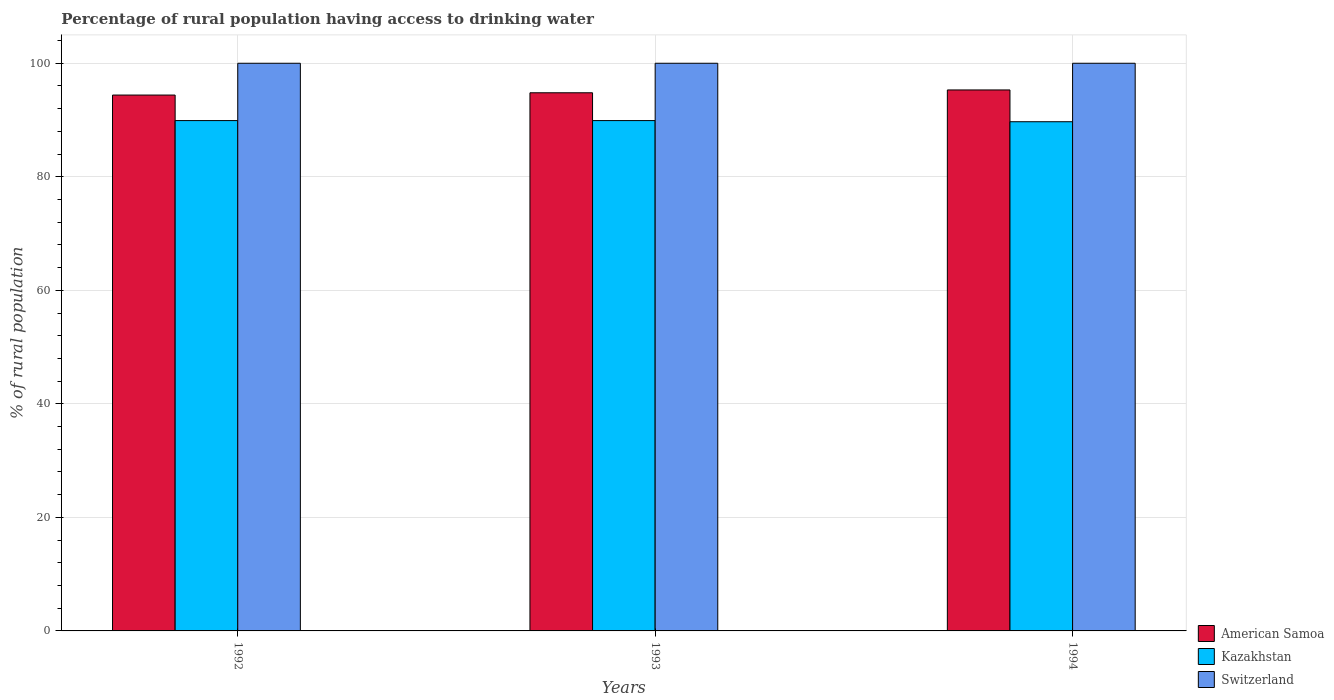How many groups of bars are there?
Offer a very short reply. 3. Are the number of bars per tick equal to the number of legend labels?
Keep it short and to the point. Yes. Are the number of bars on each tick of the X-axis equal?
Offer a very short reply. Yes. How many bars are there on the 2nd tick from the left?
Provide a short and direct response. 3. How many bars are there on the 3rd tick from the right?
Ensure brevity in your answer.  3. What is the label of the 1st group of bars from the left?
Provide a short and direct response. 1992. In how many cases, is the number of bars for a given year not equal to the number of legend labels?
Provide a succinct answer. 0. What is the percentage of rural population having access to drinking water in Kazakhstan in 1992?
Make the answer very short. 89.9. Across all years, what is the maximum percentage of rural population having access to drinking water in Kazakhstan?
Offer a very short reply. 89.9. Across all years, what is the minimum percentage of rural population having access to drinking water in Switzerland?
Your answer should be very brief. 100. In which year was the percentage of rural population having access to drinking water in Kazakhstan maximum?
Give a very brief answer. 1992. In which year was the percentage of rural population having access to drinking water in American Samoa minimum?
Your answer should be compact. 1992. What is the total percentage of rural population having access to drinking water in Switzerland in the graph?
Provide a succinct answer. 300. What is the difference between the percentage of rural population having access to drinking water in Kazakhstan in 1993 and that in 1994?
Keep it short and to the point. 0.2. What is the difference between the percentage of rural population having access to drinking water in Switzerland in 1992 and the percentage of rural population having access to drinking water in Kazakhstan in 1994?
Keep it short and to the point. 10.3. What is the average percentage of rural population having access to drinking water in American Samoa per year?
Your answer should be very brief. 94.83. In the year 1994, what is the difference between the percentage of rural population having access to drinking water in American Samoa and percentage of rural population having access to drinking water in Kazakhstan?
Make the answer very short. 5.6. What is the ratio of the percentage of rural population having access to drinking water in Kazakhstan in 1993 to that in 1994?
Your answer should be very brief. 1. Is the percentage of rural population having access to drinking water in Switzerland in 1992 less than that in 1993?
Provide a short and direct response. No. Is the difference between the percentage of rural population having access to drinking water in American Samoa in 1992 and 1993 greater than the difference between the percentage of rural population having access to drinking water in Kazakhstan in 1992 and 1993?
Your answer should be compact. No. What is the difference between the highest and the second highest percentage of rural population having access to drinking water in Switzerland?
Provide a short and direct response. 0. In how many years, is the percentage of rural population having access to drinking water in Switzerland greater than the average percentage of rural population having access to drinking water in Switzerland taken over all years?
Offer a terse response. 0. Is the sum of the percentage of rural population having access to drinking water in Switzerland in 1993 and 1994 greater than the maximum percentage of rural population having access to drinking water in American Samoa across all years?
Offer a very short reply. Yes. What does the 2nd bar from the left in 1993 represents?
Offer a terse response. Kazakhstan. What does the 2nd bar from the right in 1992 represents?
Make the answer very short. Kazakhstan. What is the difference between two consecutive major ticks on the Y-axis?
Your response must be concise. 20. Are the values on the major ticks of Y-axis written in scientific E-notation?
Your response must be concise. No. Where does the legend appear in the graph?
Your response must be concise. Bottom right. How are the legend labels stacked?
Your response must be concise. Vertical. What is the title of the graph?
Ensure brevity in your answer.  Percentage of rural population having access to drinking water. What is the label or title of the X-axis?
Keep it short and to the point. Years. What is the label or title of the Y-axis?
Provide a succinct answer. % of rural population. What is the % of rural population in American Samoa in 1992?
Provide a short and direct response. 94.4. What is the % of rural population of Kazakhstan in 1992?
Keep it short and to the point. 89.9. What is the % of rural population of Switzerland in 1992?
Your answer should be very brief. 100. What is the % of rural population of American Samoa in 1993?
Make the answer very short. 94.8. What is the % of rural population in Kazakhstan in 1993?
Give a very brief answer. 89.9. What is the % of rural population of Switzerland in 1993?
Ensure brevity in your answer.  100. What is the % of rural population in American Samoa in 1994?
Ensure brevity in your answer.  95.3. What is the % of rural population in Kazakhstan in 1994?
Make the answer very short. 89.7. What is the % of rural population in Switzerland in 1994?
Keep it short and to the point. 100. Across all years, what is the maximum % of rural population of American Samoa?
Your answer should be compact. 95.3. Across all years, what is the maximum % of rural population in Kazakhstan?
Ensure brevity in your answer.  89.9. Across all years, what is the minimum % of rural population in American Samoa?
Your answer should be compact. 94.4. Across all years, what is the minimum % of rural population of Kazakhstan?
Your response must be concise. 89.7. Across all years, what is the minimum % of rural population in Switzerland?
Provide a succinct answer. 100. What is the total % of rural population in American Samoa in the graph?
Offer a terse response. 284.5. What is the total % of rural population of Kazakhstan in the graph?
Your response must be concise. 269.5. What is the total % of rural population of Switzerland in the graph?
Provide a succinct answer. 300. What is the difference between the % of rural population in American Samoa in 1992 and that in 1993?
Your answer should be compact. -0.4. What is the difference between the % of rural population in Kazakhstan in 1992 and that in 1993?
Make the answer very short. 0. What is the difference between the % of rural population of Switzerland in 1992 and that in 1993?
Provide a succinct answer. 0. What is the difference between the % of rural population of American Samoa in 1992 and that in 1994?
Offer a very short reply. -0.9. What is the difference between the % of rural population in Kazakhstan in 1992 and that in 1994?
Offer a very short reply. 0.2. What is the difference between the % of rural population of American Samoa in 1993 and that in 1994?
Provide a short and direct response. -0.5. What is the difference between the % of rural population in Kazakhstan in 1993 and that in 1994?
Provide a succinct answer. 0.2. What is the difference between the % of rural population in Switzerland in 1993 and that in 1994?
Make the answer very short. 0. What is the difference between the % of rural population of Kazakhstan in 1992 and the % of rural population of Switzerland in 1993?
Make the answer very short. -10.1. What is the difference between the % of rural population in American Samoa in 1992 and the % of rural population in Kazakhstan in 1994?
Your answer should be compact. 4.7. What is the difference between the % of rural population of American Samoa in 1993 and the % of rural population of Switzerland in 1994?
Keep it short and to the point. -5.2. What is the average % of rural population of American Samoa per year?
Your answer should be very brief. 94.83. What is the average % of rural population of Kazakhstan per year?
Provide a succinct answer. 89.83. What is the average % of rural population in Switzerland per year?
Provide a short and direct response. 100. In the year 1992, what is the difference between the % of rural population of American Samoa and % of rural population of Kazakhstan?
Offer a terse response. 4.5. In the year 1992, what is the difference between the % of rural population in Kazakhstan and % of rural population in Switzerland?
Your response must be concise. -10.1. In the year 1993, what is the difference between the % of rural population of Kazakhstan and % of rural population of Switzerland?
Offer a terse response. -10.1. In the year 1994, what is the difference between the % of rural population in American Samoa and % of rural population in Switzerland?
Give a very brief answer. -4.7. In the year 1994, what is the difference between the % of rural population of Kazakhstan and % of rural population of Switzerland?
Give a very brief answer. -10.3. What is the ratio of the % of rural population in Kazakhstan in 1992 to that in 1993?
Give a very brief answer. 1. What is the ratio of the % of rural population of American Samoa in 1992 to that in 1994?
Ensure brevity in your answer.  0.99. What is the ratio of the % of rural population in Switzerland in 1992 to that in 1994?
Provide a short and direct response. 1. What is the ratio of the % of rural population in Switzerland in 1993 to that in 1994?
Your answer should be very brief. 1. What is the difference between the highest and the lowest % of rural population of American Samoa?
Your response must be concise. 0.9. 